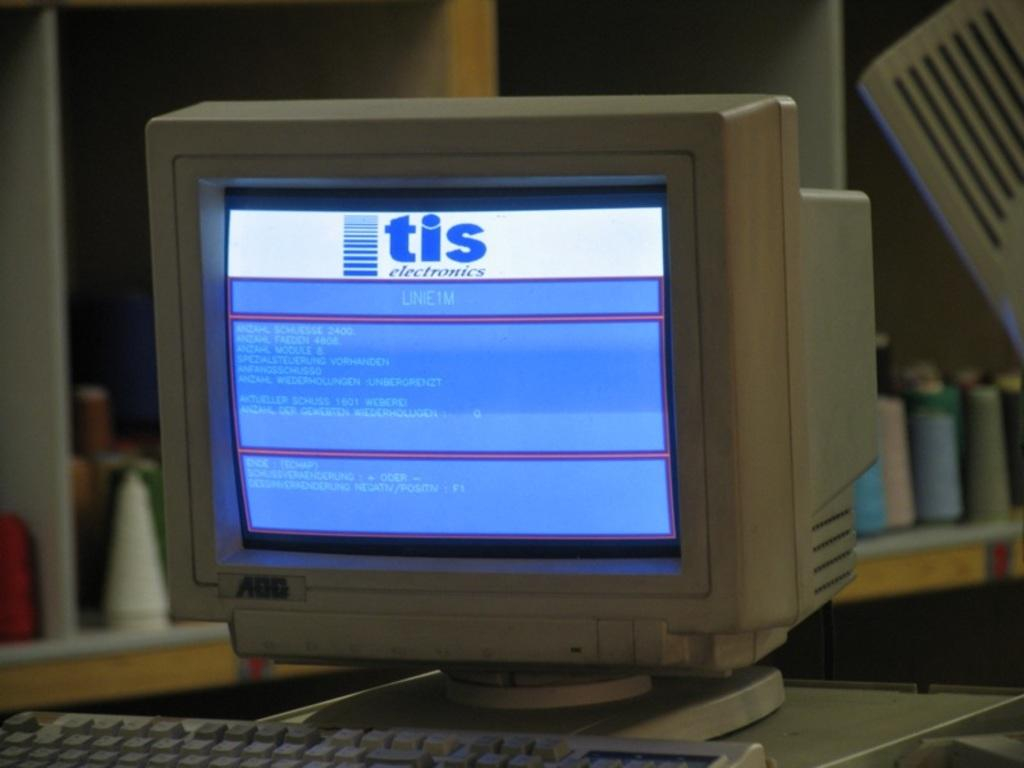<image>
Provide a brief description of the given image. An old AOC crt monitor running software from TIS electronics. 